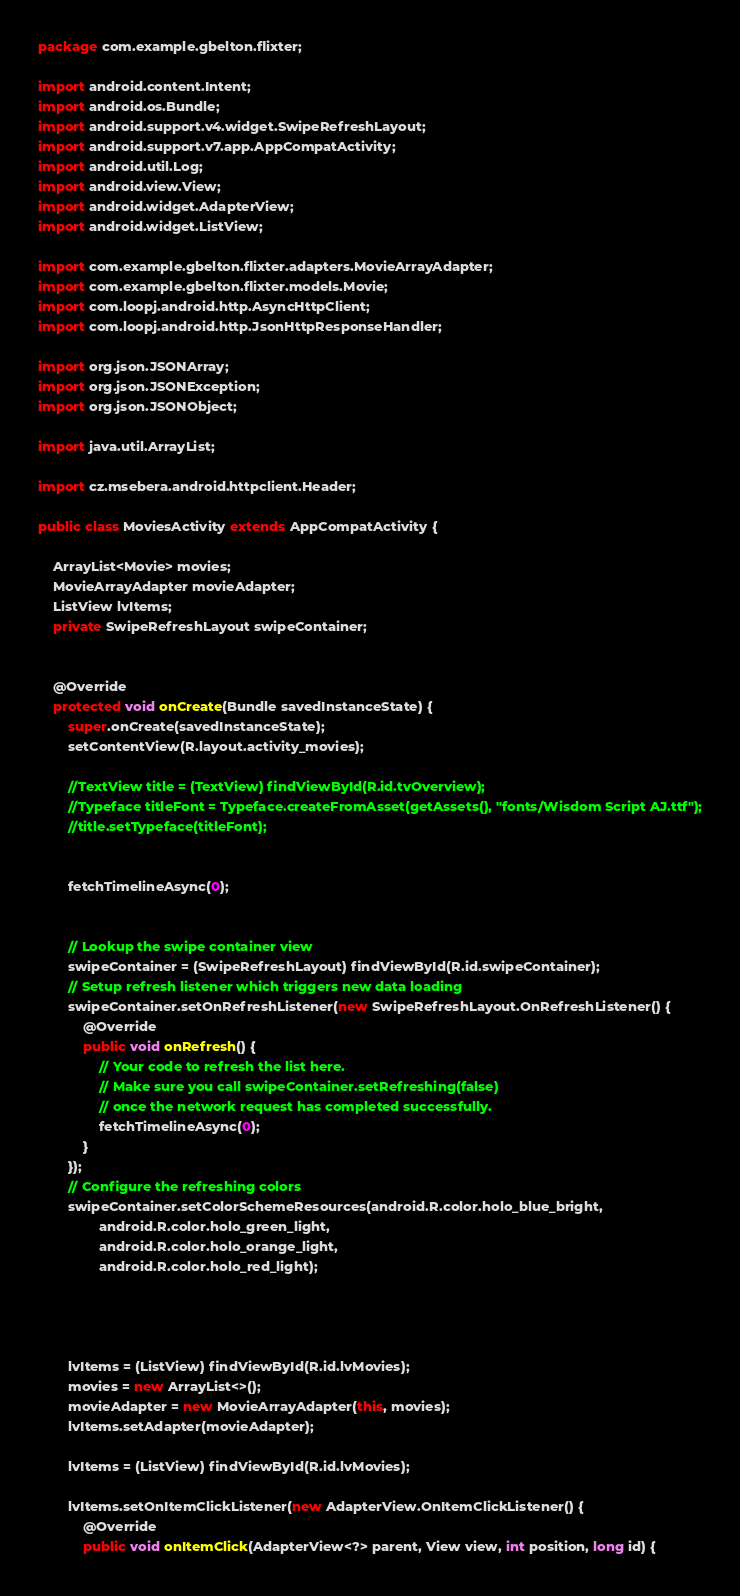Convert code to text. <code><loc_0><loc_0><loc_500><loc_500><_Java_>package com.example.gbelton.flixter;

import android.content.Intent;
import android.os.Bundle;
import android.support.v4.widget.SwipeRefreshLayout;
import android.support.v7.app.AppCompatActivity;
import android.util.Log;
import android.view.View;
import android.widget.AdapterView;
import android.widget.ListView;

import com.example.gbelton.flixter.adapters.MovieArrayAdapter;
import com.example.gbelton.flixter.models.Movie;
import com.loopj.android.http.AsyncHttpClient;
import com.loopj.android.http.JsonHttpResponseHandler;

import org.json.JSONArray;
import org.json.JSONException;
import org.json.JSONObject;

import java.util.ArrayList;

import cz.msebera.android.httpclient.Header;

public class MoviesActivity extends AppCompatActivity {

    ArrayList<Movie> movies;
    MovieArrayAdapter movieAdapter;
    ListView lvItems;
    private SwipeRefreshLayout swipeContainer;


    @Override
    protected void onCreate(Bundle savedInstanceState) {
        super.onCreate(savedInstanceState);
        setContentView(R.layout.activity_movies);

        //TextView title = (TextView) findViewById(R.id.tvOverview);
        //Typeface titleFont = Typeface.createFromAsset(getAssets(), "fonts/Wisdom Script AJ.ttf");
        //title.setTypeface(titleFont);


        fetchTimelineAsync(0);


        // Lookup the swipe container view
        swipeContainer = (SwipeRefreshLayout) findViewById(R.id.swipeContainer);
        // Setup refresh listener which triggers new data loading
        swipeContainer.setOnRefreshListener(new SwipeRefreshLayout.OnRefreshListener() {
            @Override
            public void onRefresh() {
                // Your code to refresh the list here.
                // Make sure you call swipeContainer.setRefreshing(false)
                // once the network request has completed successfully.
                fetchTimelineAsync(0);
            }
        });
        // Configure the refreshing colors
        swipeContainer.setColorSchemeResources(android.R.color.holo_blue_bright,
                android.R.color.holo_green_light,
                android.R.color.holo_orange_light,
                android.R.color.holo_red_light);




        lvItems = (ListView) findViewById(R.id.lvMovies);
        movies = new ArrayList<>();
        movieAdapter = new MovieArrayAdapter(this, movies);
        lvItems.setAdapter(movieAdapter);

        lvItems = (ListView) findViewById(R.id.lvMovies);

        lvItems.setOnItemClickListener(new AdapterView.OnItemClickListener() {
            @Override
            public void onItemClick(AdapterView<?> parent, View view, int position, long id) {</code> 